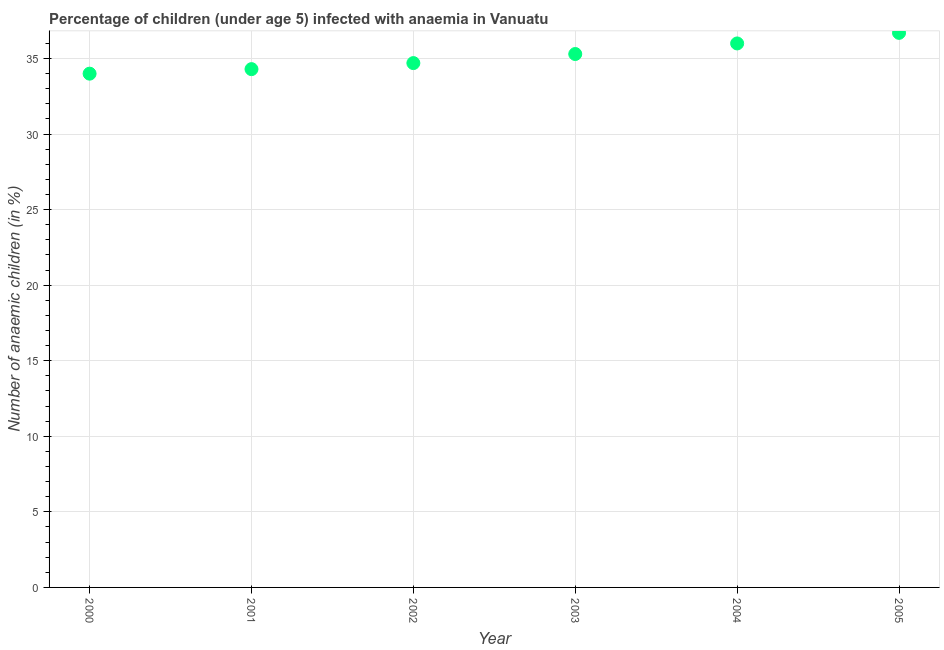What is the number of anaemic children in 2005?
Provide a succinct answer. 36.7. Across all years, what is the maximum number of anaemic children?
Your answer should be compact. 36.7. In which year was the number of anaemic children minimum?
Ensure brevity in your answer.  2000. What is the sum of the number of anaemic children?
Your answer should be compact. 211. What is the difference between the number of anaemic children in 2000 and 2002?
Your answer should be compact. -0.7. What is the average number of anaemic children per year?
Your answer should be compact. 35.17. What is the median number of anaemic children?
Offer a very short reply. 35. In how many years, is the number of anaemic children greater than 6 %?
Ensure brevity in your answer.  6. Do a majority of the years between 2001 and 2003 (inclusive) have number of anaemic children greater than 5 %?
Your answer should be very brief. Yes. What is the ratio of the number of anaemic children in 2000 to that in 2003?
Provide a succinct answer. 0.96. Is the number of anaemic children in 2002 less than that in 2003?
Ensure brevity in your answer.  Yes. What is the difference between the highest and the second highest number of anaemic children?
Provide a short and direct response. 0.7. Is the sum of the number of anaemic children in 2004 and 2005 greater than the maximum number of anaemic children across all years?
Provide a succinct answer. Yes. What is the difference between the highest and the lowest number of anaemic children?
Make the answer very short. 2.7. How many dotlines are there?
Make the answer very short. 1. Does the graph contain grids?
Your answer should be compact. Yes. What is the title of the graph?
Your answer should be very brief. Percentage of children (under age 5) infected with anaemia in Vanuatu. What is the label or title of the Y-axis?
Your answer should be compact. Number of anaemic children (in %). What is the Number of anaemic children (in %) in 2000?
Make the answer very short. 34. What is the Number of anaemic children (in %) in 2001?
Your answer should be compact. 34.3. What is the Number of anaemic children (in %) in 2002?
Give a very brief answer. 34.7. What is the Number of anaemic children (in %) in 2003?
Provide a short and direct response. 35.3. What is the Number of anaemic children (in %) in 2005?
Provide a short and direct response. 36.7. What is the difference between the Number of anaemic children (in %) in 2000 and 2001?
Offer a very short reply. -0.3. What is the difference between the Number of anaemic children (in %) in 2000 and 2002?
Provide a succinct answer. -0.7. What is the difference between the Number of anaemic children (in %) in 2000 and 2003?
Provide a short and direct response. -1.3. What is the difference between the Number of anaemic children (in %) in 2000 and 2005?
Your response must be concise. -2.7. What is the difference between the Number of anaemic children (in %) in 2001 and 2005?
Provide a succinct answer. -2.4. What is the difference between the Number of anaemic children (in %) in 2002 and 2004?
Give a very brief answer. -1.3. What is the difference between the Number of anaemic children (in %) in 2002 and 2005?
Provide a short and direct response. -2. What is the difference between the Number of anaemic children (in %) in 2003 and 2004?
Give a very brief answer. -0.7. What is the difference between the Number of anaemic children (in %) in 2004 and 2005?
Make the answer very short. -0.7. What is the ratio of the Number of anaemic children (in %) in 2000 to that in 2001?
Your answer should be compact. 0.99. What is the ratio of the Number of anaemic children (in %) in 2000 to that in 2002?
Offer a terse response. 0.98. What is the ratio of the Number of anaemic children (in %) in 2000 to that in 2004?
Your answer should be compact. 0.94. What is the ratio of the Number of anaemic children (in %) in 2000 to that in 2005?
Give a very brief answer. 0.93. What is the ratio of the Number of anaemic children (in %) in 2001 to that in 2002?
Your response must be concise. 0.99. What is the ratio of the Number of anaemic children (in %) in 2001 to that in 2004?
Give a very brief answer. 0.95. What is the ratio of the Number of anaemic children (in %) in 2001 to that in 2005?
Make the answer very short. 0.94. What is the ratio of the Number of anaemic children (in %) in 2002 to that in 2004?
Ensure brevity in your answer.  0.96. What is the ratio of the Number of anaemic children (in %) in 2002 to that in 2005?
Your answer should be very brief. 0.95. What is the ratio of the Number of anaemic children (in %) in 2003 to that in 2005?
Give a very brief answer. 0.96. 